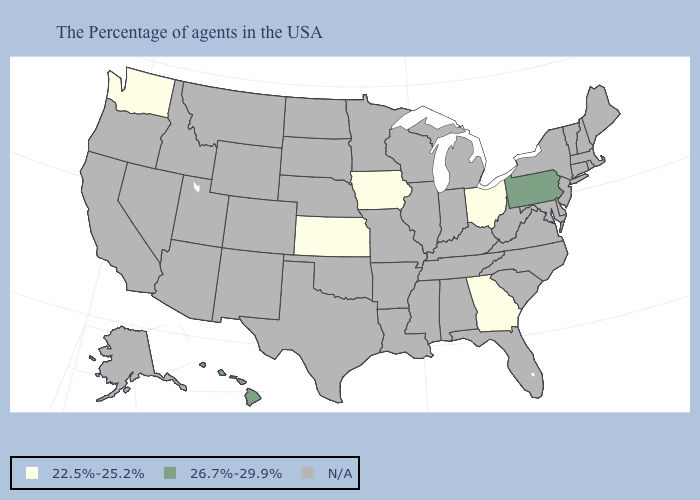What is the value of Texas?
Give a very brief answer. N/A. Does Pennsylvania have the highest value in the USA?
Concise answer only. Yes. What is the value of Hawaii?
Write a very short answer. 26.7%-29.9%. Name the states that have a value in the range 22.5%-25.2%?
Answer briefly. Ohio, Georgia, Iowa, Kansas, Washington. Which states hav the highest value in the West?
Concise answer only. Hawaii. Which states hav the highest value in the Northeast?
Concise answer only. Pennsylvania. What is the lowest value in states that border North Carolina?
Short answer required. 22.5%-25.2%. Name the states that have a value in the range N/A?
Be succinct. Maine, Massachusetts, Rhode Island, New Hampshire, Vermont, Connecticut, New York, New Jersey, Delaware, Maryland, Virginia, North Carolina, South Carolina, West Virginia, Florida, Michigan, Kentucky, Indiana, Alabama, Tennessee, Wisconsin, Illinois, Mississippi, Louisiana, Missouri, Arkansas, Minnesota, Nebraska, Oklahoma, Texas, South Dakota, North Dakota, Wyoming, Colorado, New Mexico, Utah, Montana, Arizona, Idaho, Nevada, California, Oregon, Alaska. Does the map have missing data?
Be succinct. Yes. Does Hawaii have the highest value in the USA?
Write a very short answer. Yes. 